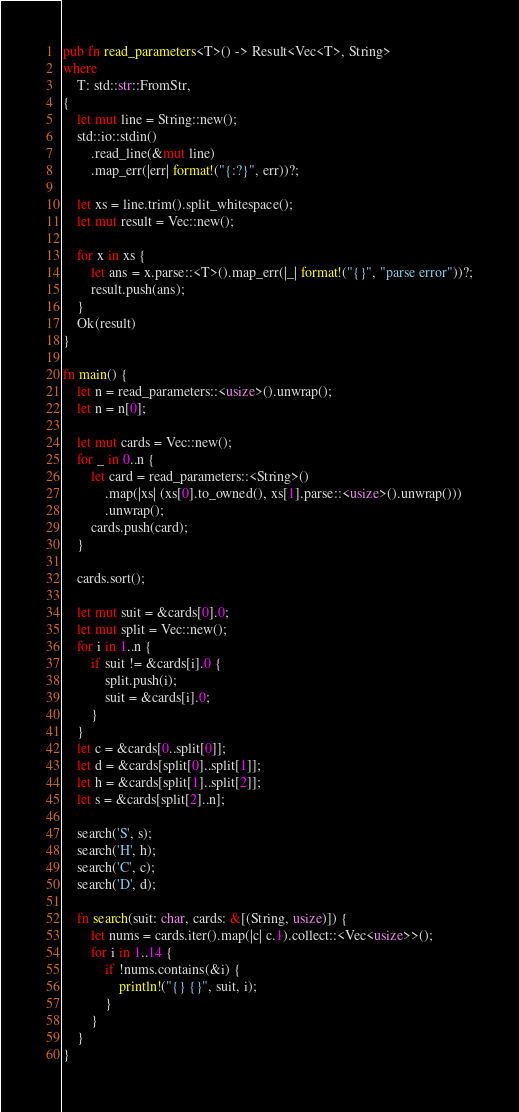Convert code to text. <code><loc_0><loc_0><loc_500><loc_500><_Rust_>pub fn read_parameters<T>() -> Result<Vec<T>, String>
where
    T: std::str::FromStr,
{
    let mut line = String::new();
    std::io::stdin()
        .read_line(&mut line)
        .map_err(|err| format!("{:?}", err))?;

    let xs = line.trim().split_whitespace();
    let mut result = Vec::new();

    for x in xs {
        let ans = x.parse::<T>().map_err(|_| format!("{}", "parse error"))?;
        result.push(ans);
    }
    Ok(result)
}

fn main() {
    let n = read_parameters::<usize>().unwrap();
    let n = n[0];

    let mut cards = Vec::new();
    for _ in 0..n {
        let card = read_parameters::<String>()
            .map(|xs| (xs[0].to_owned(), xs[1].parse::<usize>().unwrap()))
            .unwrap();
        cards.push(card);
    }

    cards.sort();

    let mut suit = &cards[0].0;
    let mut split = Vec::new();
    for i in 1..n {
        if suit != &cards[i].0 {
            split.push(i);
            suit = &cards[i].0;
        }
    }
    let c = &cards[0..split[0]];
    let d = &cards[split[0]..split[1]];
    let h = &cards[split[1]..split[2]];
    let s = &cards[split[2]..n];

    search('S', s);
    search('H', h);
    search('C', c);
    search('D', d);

    fn search(suit: char, cards: &[(String, usize)]) {
        let nums = cards.iter().map(|c| c.1).collect::<Vec<usize>>();
        for i in 1..14 {
            if !nums.contains(&i) {
                println!("{} {}", suit, i);
            }
        }
    }
}

</code> 